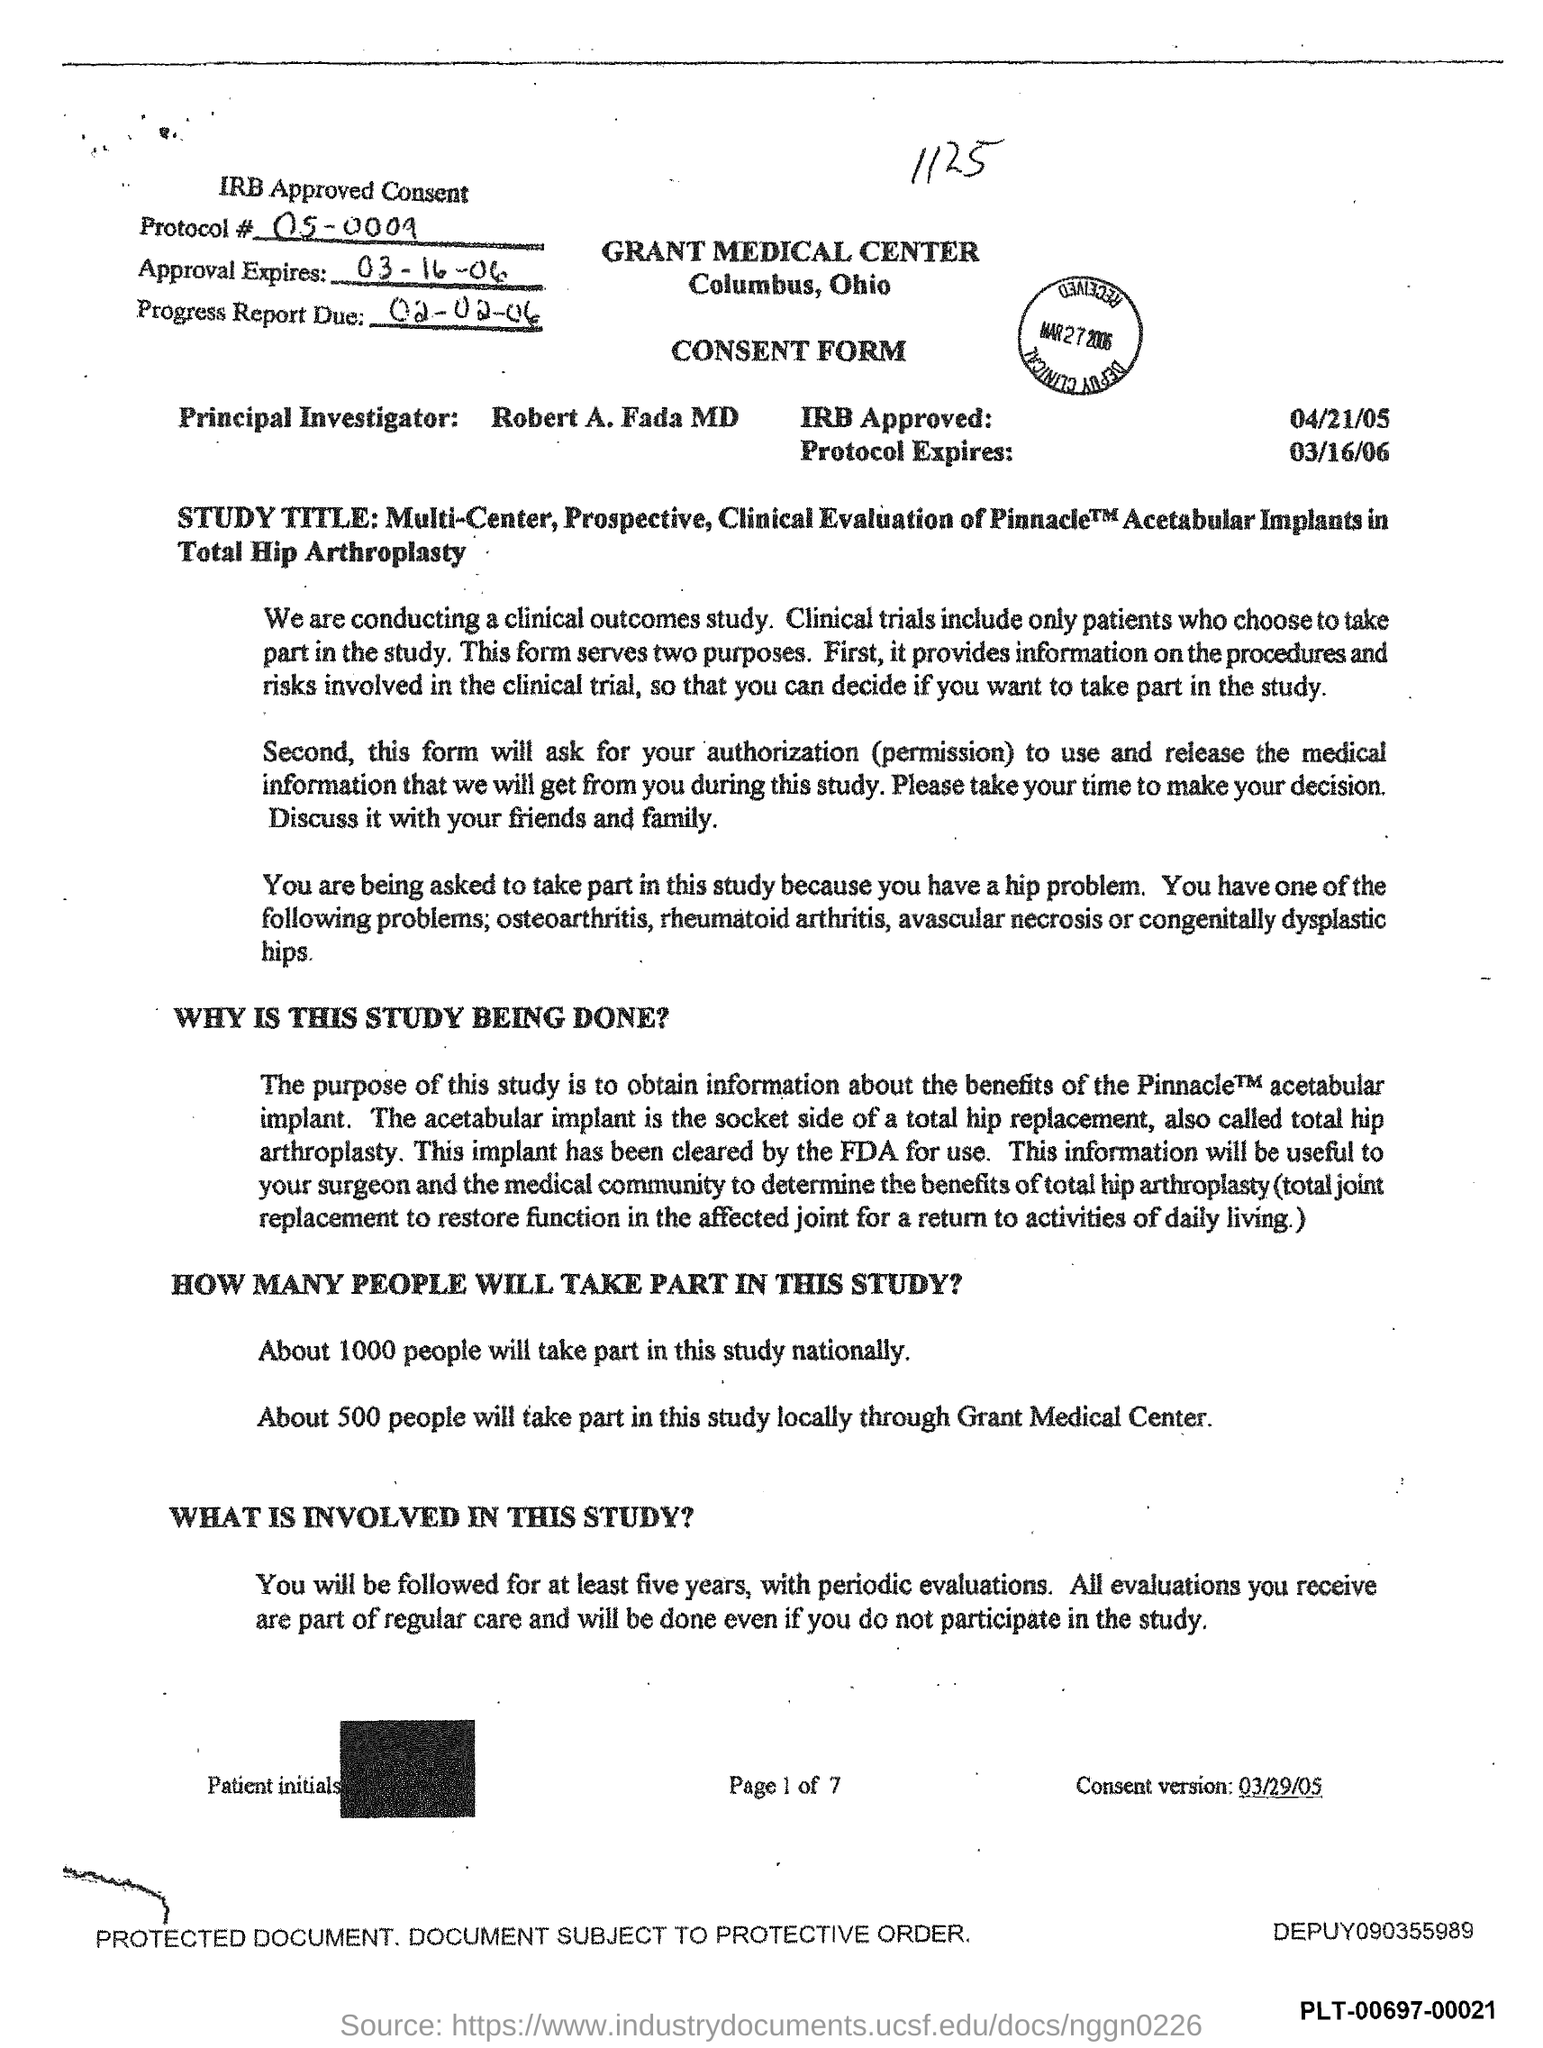What is the Protocol # number?
Your response must be concise. 05-0009. On which date the approval expires?
Keep it short and to the point. 03-16-06. On which date the protocol expires?
Your response must be concise. 03/16/06. On which date IRB approved?
Your answer should be very brief. 04/21/05. 